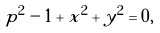Convert formula to latex. <formula><loc_0><loc_0><loc_500><loc_500>p ^ { 2 } - 1 + x ^ { 2 } + y ^ { 2 } = 0 ,</formula> 